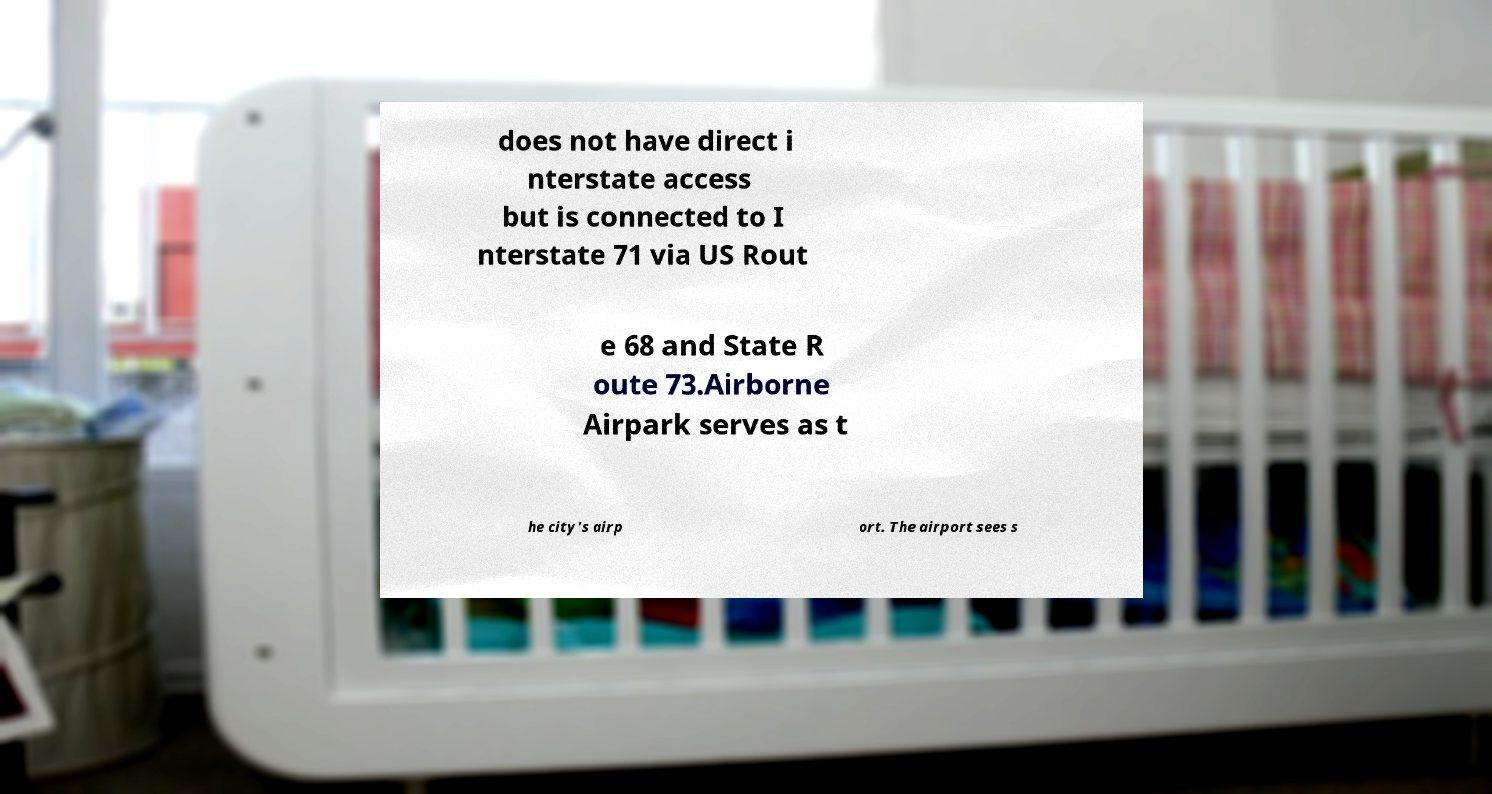Can you read and provide the text displayed in the image?This photo seems to have some interesting text. Can you extract and type it out for me? does not have direct i nterstate access but is connected to I nterstate 71 via US Rout e 68 and State R oute 73.Airborne Airpark serves as t he city's airp ort. The airport sees s 